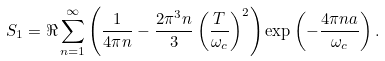Convert formula to latex. <formula><loc_0><loc_0><loc_500><loc_500>S _ { 1 } = \Re \sum _ { n = 1 } ^ { \infty } \left ( \frac { 1 } { 4 \pi n } - \frac { 2 \pi ^ { 3 } n } { 3 } \left ( \frac { T } { \omega _ { c } } \right ) ^ { 2 } \right ) \exp \left ( - \frac { 4 \pi n a } { \omega _ { c } } \right ) .</formula> 